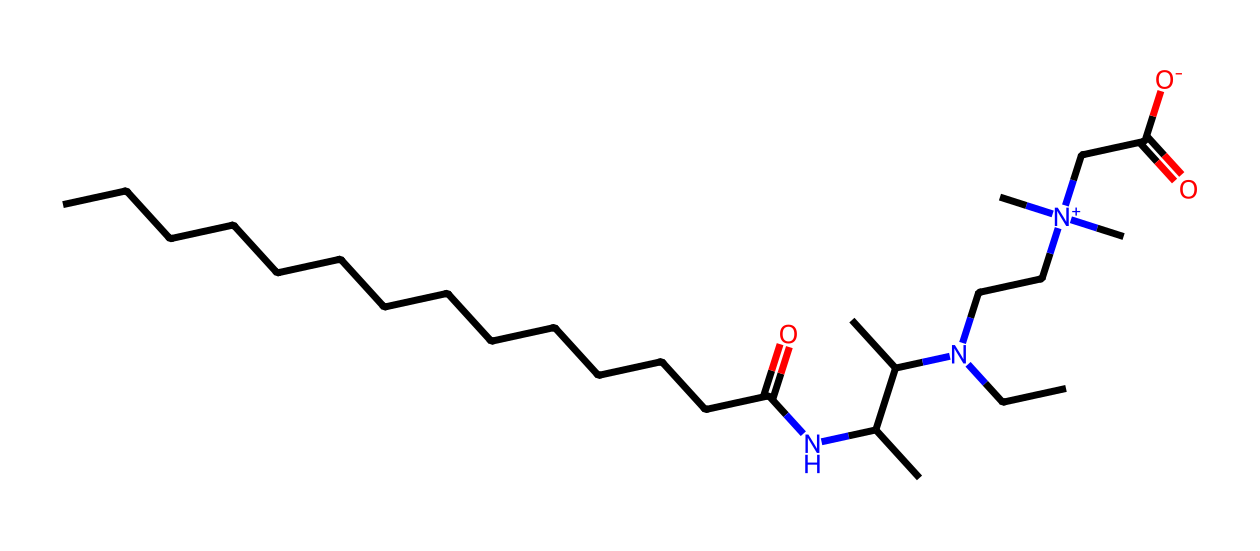What is the name of this surfactant? The chemical structure corresponds to cocamidopropyl betaine, a well-known surfactant found in personal care products. The name is derived from its components; 'cocami' refers to coconut oil derivatives, 'propyl' refers to the propyl group, and 'betaine' is due to its zwitterionic nature.
Answer: cocamidopropyl betaine How many carbon atoms are present in the structure? Counting the carbon atoms in the SMILES representation, there are 20 carbon atoms associated with the long hydrocarbon chain and branching structures.
Answer: 20 What type of functional groups are found in this molecule? This molecule contains an amine group (N), a carboxylic acid group (-COOH), and a quaternary ammonium group ([N+]). These functional groups give cocamidopropyl betaine its surfactant properties.
Answer: amine, carboxylic acid, quaternary ammonium Does this surfactant have a hydrophilic or hydrophobic nature? Cocamidopropyl betaine has both hydrophilic (due to the presence of the carboxylic acid and quaternary ammonium groups) and hydrophobic characteristics (from the long hydrocarbon tail), which is typical of surfactants that facilitate emulsification.
Answer: amphiphilic How does the quaternary ammonium group affect the surfactant's properties? The quaternary ammonium group increases the solubility in water due to its positive charge, enhancing the surfactant's ability to interact with water and oil, promoting better wetting and foaming properties.
Answer: increases solubility What is the significance of the amine group in this surfactant? The presence of the amine group contributes to the zwitterionic nature of cocamidopropyl betaine, which allows it to function effectively in cleansing and foaming, as well as providing mildness for sensitive skin types.
Answer: zwitterionic nature 